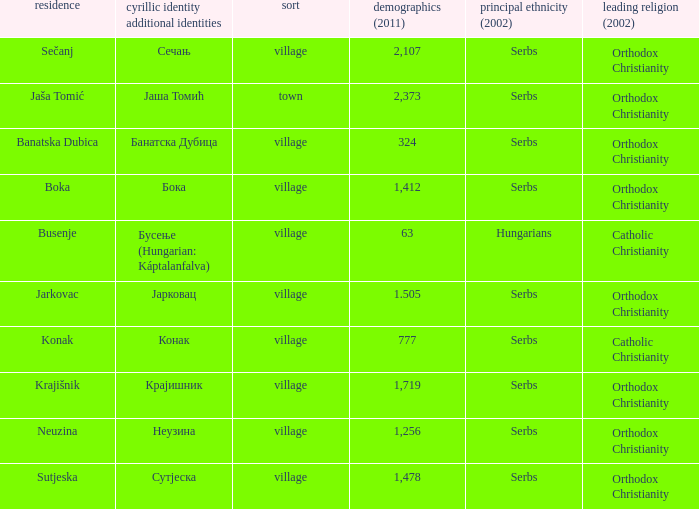What town has the population of 777? Конак. 